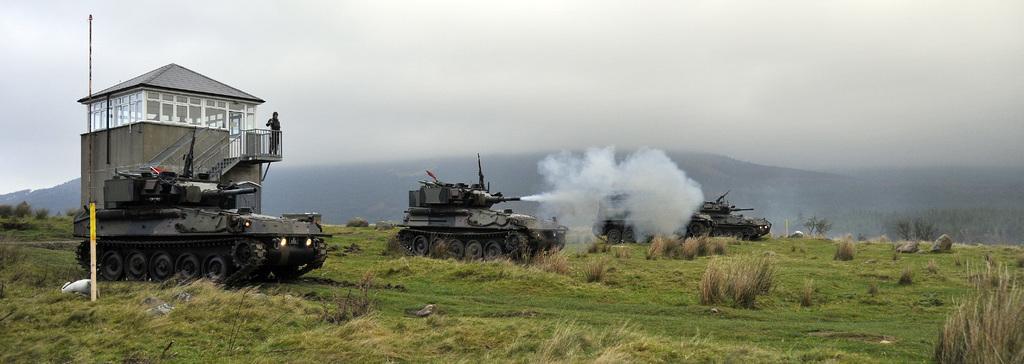Please provide a concise description of this image. In this image there are few army tanks on the surface of the grass, behind them there is a building and there is a person standing. In the background there are mountains and the sky. 